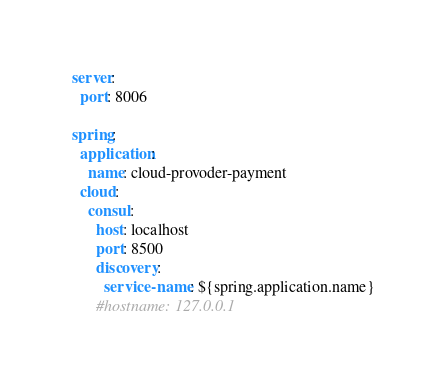Convert code to text. <code><loc_0><loc_0><loc_500><loc_500><_YAML_>server:
  port: 8006

spring:
  application:
    name: cloud-provoder-payment
  cloud:
    consul:
      host: localhost
      port: 8500
      discovery:
        service-name: ${spring.application.name}
      #hostname: 127.0.0.1

</code> 